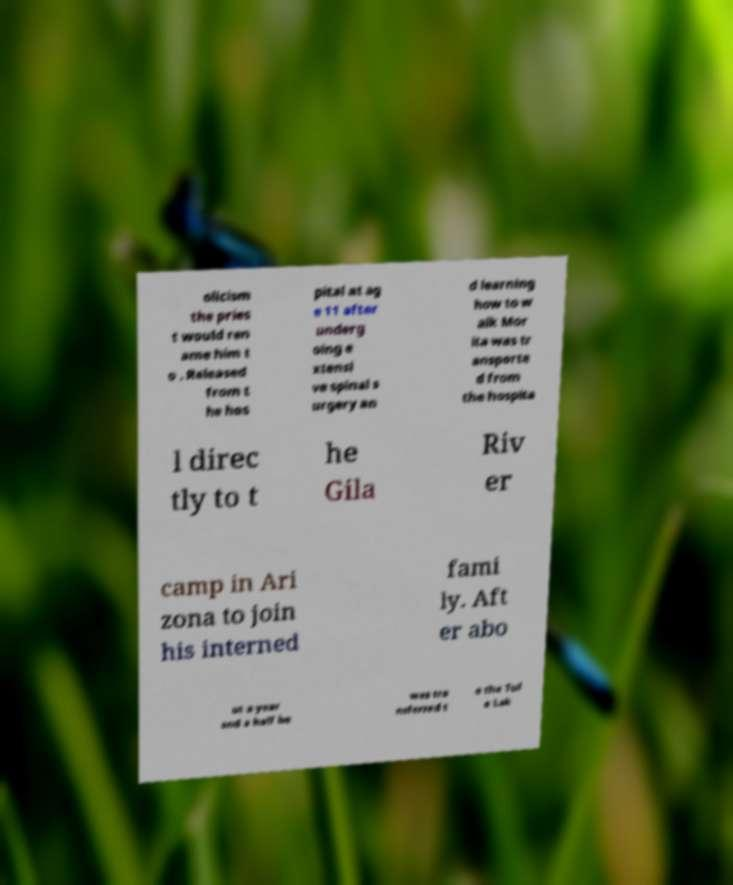For documentation purposes, I need the text within this image transcribed. Could you provide that? olicism the pries t would ren ame him t o . Released from t he hos pital at ag e 11 after underg oing e xtensi ve spinal s urgery an d learning how to w alk Mor ita was tr ansporte d from the hospita l direc tly to t he Gila Riv er camp in Ari zona to join his interned fami ly. Aft er abo ut a year and a half he was tra nsferred t o the Tul e Lak 